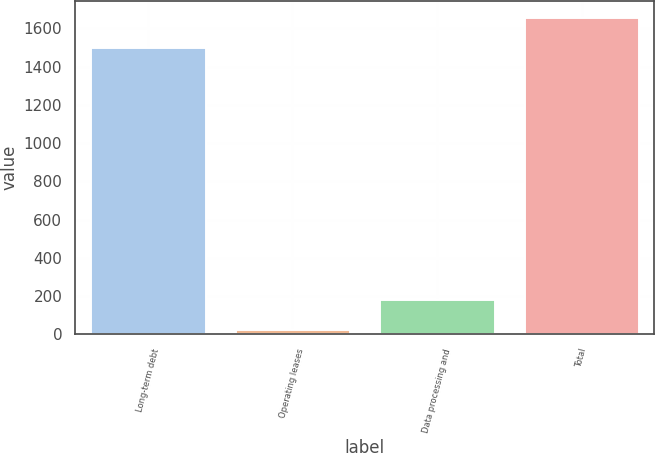Convert chart. <chart><loc_0><loc_0><loc_500><loc_500><bar_chart><fcel>Long-term debt<fcel>Operating leases<fcel>Data processing and<fcel>Total<nl><fcel>1504.8<fcel>27.8<fcel>184.57<fcel>1661.57<nl></chart> 